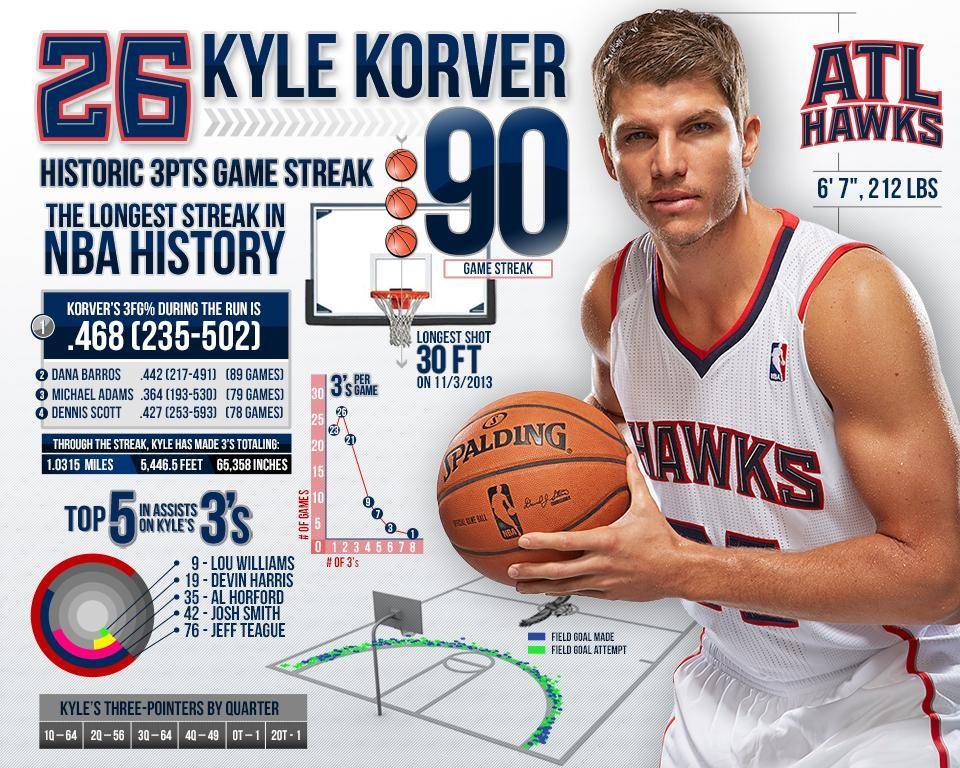Who are the 2 topmost assists on Kyle Korver's 3 pointers?
Answer the question with a short phrase. Jeff Teague, Josh Smith What is Kyle Korver's jersey number? 26 What is his height? 6'7" What is his weight? 212LBS What was his longest shot and when did he make it? 30FT, 11/3/2013 Who had the second highest 3fg percent? Dana Barros What is the team name written on his Jersey? Hawks What was Kyle Korver's highest game streak? 90 What was Korver's 3fg %? .468 [235-502] Who had the highest 3fg percent? Kyle korver How many 3 pointers did he make in the fourth quarter? 49 How many 3 pointers did he make in the first quarter? 64 